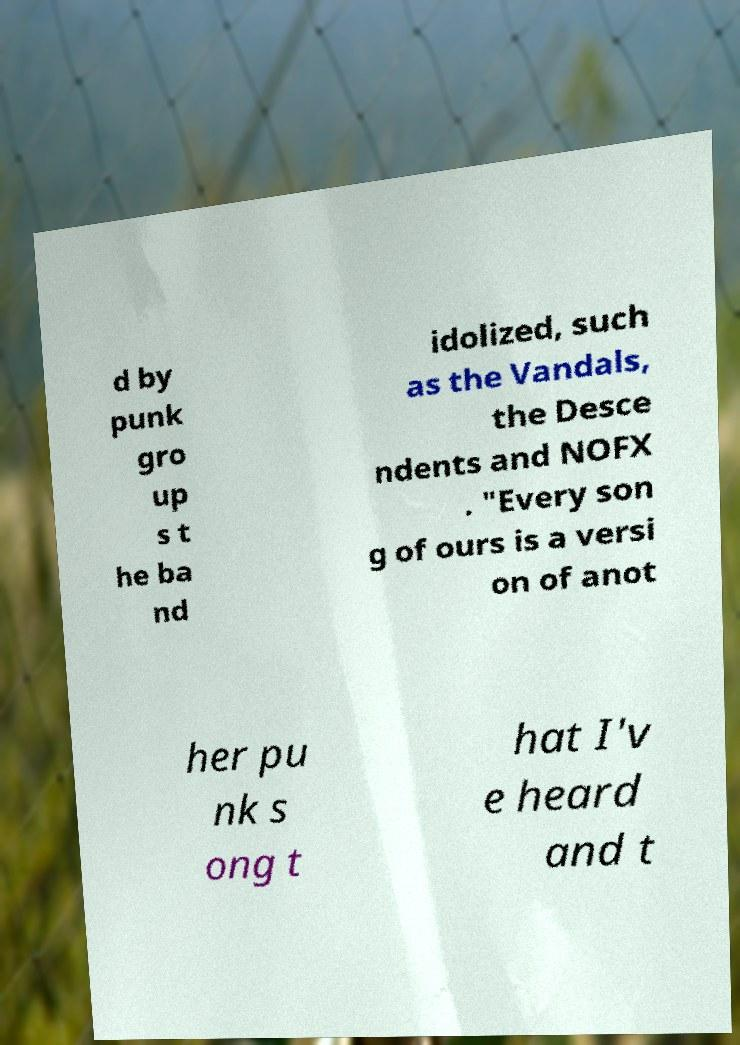Can you read and provide the text displayed in the image?This photo seems to have some interesting text. Can you extract and type it out for me? d by punk gro up s t he ba nd idolized, such as the Vandals, the Desce ndents and NOFX . "Every son g of ours is a versi on of anot her pu nk s ong t hat I'v e heard and t 